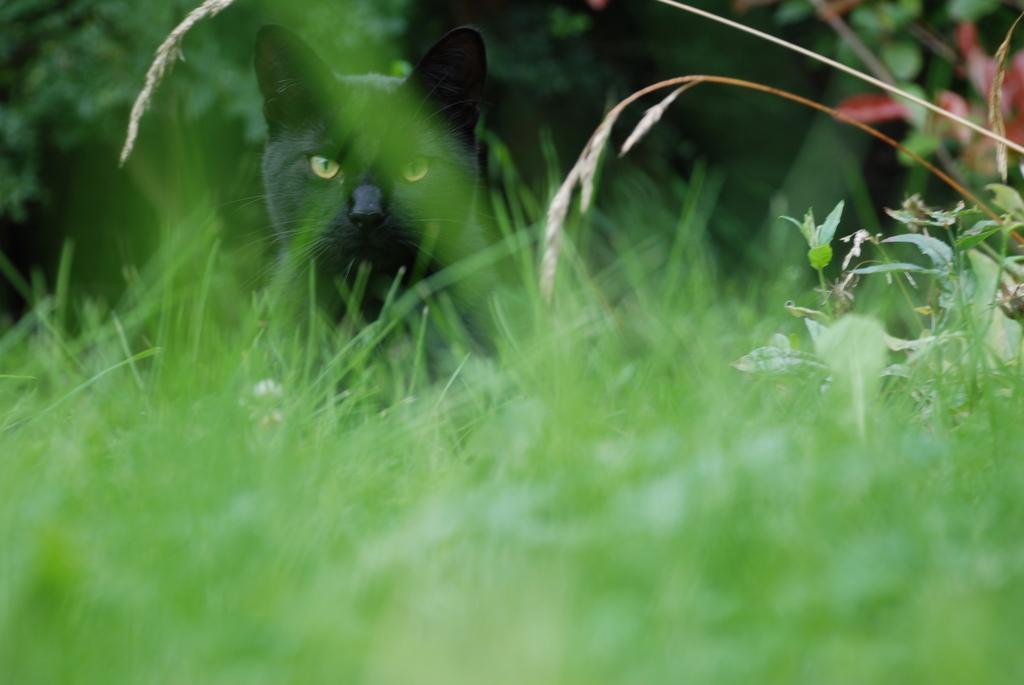Can you describe this image briefly? At the bottom of this image I can see the grass. On the right side there are few plants. In the middle of the image there is a black color cat looking at the picture. In the background there are few trees. 